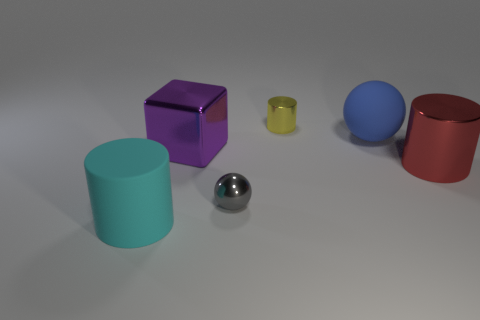Is the number of gray metallic spheres that are behind the tiny ball less than the number of big shiny objects?
Keep it short and to the point. Yes. Is the number of gray balls to the left of the gray sphere greater than the number of matte cylinders behind the purple shiny object?
Ensure brevity in your answer.  No. Is there anything else that has the same color as the metal sphere?
Your response must be concise. No. There is a small yellow cylinder to the left of the blue rubber sphere; what material is it?
Your answer should be compact. Metal. Is the size of the cyan rubber thing the same as the gray object?
Your answer should be compact. No. What number of other things are there of the same size as the blue rubber sphere?
Ensure brevity in your answer.  3. Does the shiny sphere have the same color as the tiny cylinder?
Offer a very short reply. No. What shape is the big thing that is in front of the tiny object that is in front of the sphere on the right side of the shiny ball?
Provide a short and direct response. Cylinder. What number of things are big things that are behind the large cyan cylinder or big objects left of the yellow cylinder?
Keep it short and to the point. 4. What is the size of the matte thing right of the big thing in front of the small gray ball?
Your answer should be very brief. Large. 